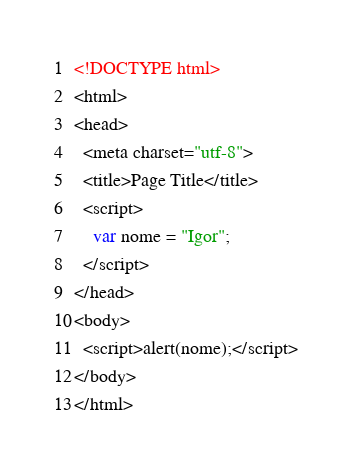<code> <loc_0><loc_0><loc_500><loc_500><_HTML_><!DOCTYPE html>
<html>
<head>
  <meta charset="utf-8">
  <title>Page Title</title>
  <script>
    var nome = "Igor";
  </script>
</head>
<body>
  <script>alert(nome);</script>
</body>
</html></code> 